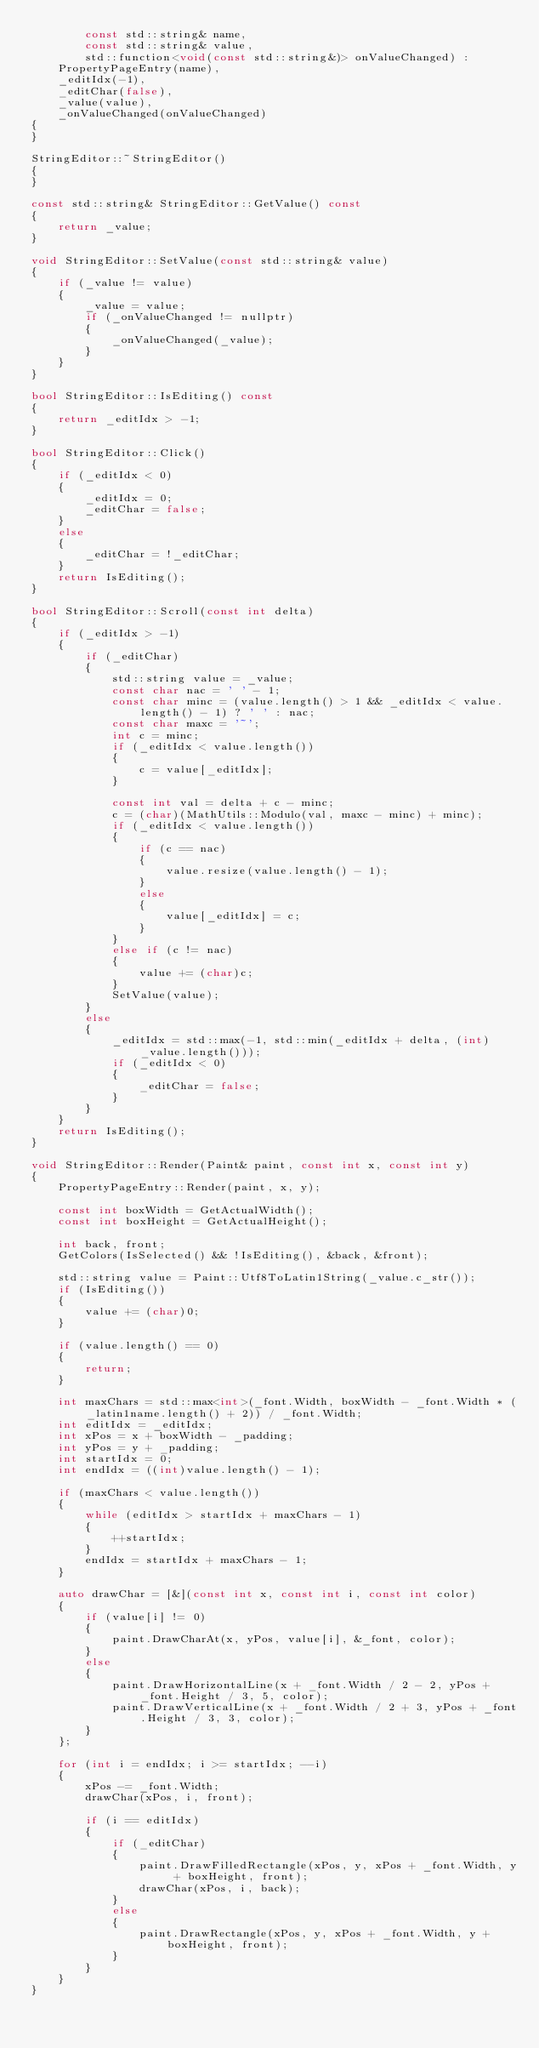Convert code to text. <code><loc_0><loc_0><loc_500><loc_500><_C++_>        const std::string& name,
        const std::string& value,
        std::function<void(const std::string&)> onValueChanged) :
    PropertyPageEntry(name),
    _editIdx(-1),
    _editChar(false),
    _value(value),
    _onValueChanged(onValueChanged)
{
}

StringEditor::~StringEditor()
{
}

const std::string& StringEditor::GetValue() const
{
    return _value;
}

void StringEditor::SetValue(const std::string& value)
{
    if (_value != value)
    {
        _value = value;
        if (_onValueChanged != nullptr)
        {
            _onValueChanged(_value);
        }
    }
}

bool StringEditor::IsEditing() const
{
    return _editIdx > -1;
}

bool StringEditor::Click()
{
    if (_editIdx < 0)
    {
        _editIdx = 0;
        _editChar = false;
    }
    else
    {
        _editChar = !_editChar;
    }
    return IsEditing();
}

bool StringEditor::Scroll(const int delta)
{
    if (_editIdx > -1)
    {
        if (_editChar)
        {
            std::string value = _value;
            const char nac = ' ' - 1;
            const char minc = (value.length() > 1 && _editIdx < value.length() - 1) ? ' ' : nac;
            const char maxc = '~';
            int c = minc;
            if (_editIdx < value.length())
            {
                c = value[_editIdx];
            }

            const int val = delta + c - minc;
            c = (char)(MathUtils::Modulo(val, maxc - minc) + minc);
            if (_editIdx < value.length())
            {
                if (c == nac)
                {
                    value.resize(value.length() - 1);
                }
                else
                {
                    value[_editIdx] = c;
                }
            }
            else if (c != nac)
            {
                value += (char)c;
            }
            SetValue(value);
        }
        else
        {
            _editIdx = std::max(-1, std::min(_editIdx + delta, (int)_value.length()));
            if (_editIdx < 0)
            {
                _editChar = false;
            }
        }
    }
    return IsEditing();
}

void StringEditor::Render(Paint& paint, const int x, const int y)
{
    PropertyPageEntry::Render(paint, x, y);
    
    const int boxWidth = GetActualWidth();
    const int boxHeight = GetActualHeight();

    int back, front;
    GetColors(IsSelected() && !IsEditing(), &back, &front);

    std::string value = Paint::Utf8ToLatin1String(_value.c_str());
    if (IsEditing())
    {
        value += (char)0;
    }

    if (value.length() == 0)
    {
        return;
    }

    int maxChars = std::max<int>(_font.Width, boxWidth - _font.Width * (_latin1name.length() + 2)) / _font.Width;
    int editIdx = _editIdx;
    int xPos = x + boxWidth - _padding;
    int yPos = y + _padding;
    int startIdx = 0;
    int endIdx = ((int)value.length() - 1);    

    if (maxChars < value.length())
    {
        while (editIdx > startIdx + maxChars - 1)
        {
            ++startIdx;
        }
        endIdx = startIdx + maxChars - 1;
    }

    auto drawChar = [&](const int x, const int i, const int color)
    {
        if (value[i] != 0)
        {
            paint.DrawCharAt(x, yPos, value[i], &_font, color);
        }
        else
        {
            paint.DrawHorizontalLine(x + _font.Width / 2 - 2, yPos + _font.Height / 3, 5, color);
            paint.DrawVerticalLine(x + _font.Width / 2 + 3, yPos + _font.Height / 3, 3, color);
        }
    };

    for (int i = endIdx; i >= startIdx; --i)
    {
        xPos -= _font.Width;
        drawChar(xPos, i, front);

        if (i == editIdx)
        {
            if (_editChar)
            {
                paint.DrawFilledRectangle(xPos, y, xPos + _font.Width, y + boxHeight, front);
                drawChar(xPos, i, back);
            }
            else
            {
                paint.DrawRectangle(xPos, y, xPos + _font.Width, y + boxHeight, front);
            }
        }
    }
}</code> 